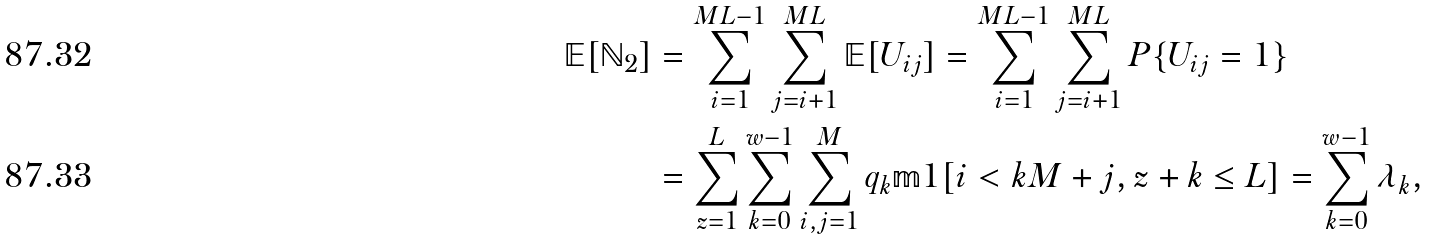<formula> <loc_0><loc_0><loc_500><loc_500>\mathbb { E } [ \mathbb { N } _ { 2 } ] & = \sum _ { i = 1 } ^ { M L - 1 } \sum _ { j = i + 1 } ^ { M L } \mathbb { E } [ U _ { i j } ] = \sum _ { i = 1 } ^ { M L - 1 } \sum _ { j = i + 1 } ^ { M L } P \{ U _ { i j } = 1 \} \\ & = \sum _ { z = 1 } ^ { L } \sum _ { k = 0 } ^ { w - 1 } \sum _ { i , j = 1 } ^ { M } q _ { k } \mathbb { m } { 1 } [ i < k M + j , z + k \leq L ] = \sum _ { k = 0 } ^ { w - 1 } \lambda _ { k } ,</formula> 